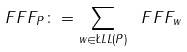<formula> <loc_0><loc_0><loc_500><loc_500>\ F F F _ { P } \colon = \sum _ { w \in \L L L ( P ) } \ F F F _ { w }</formula> 